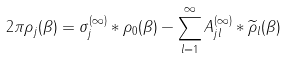Convert formula to latex. <formula><loc_0><loc_0><loc_500><loc_500>2 \pi { \rho } _ { j } ( \beta ) = \sigma _ { j } ^ { ( \infty ) } * \rho _ { 0 } ( \beta ) - \sum _ { l = 1 } ^ { \infty } A _ { j l } ^ { ( \infty ) } * \widetilde { \rho } _ { l } ( \beta )</formula> 